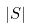<formula> <loc_0><loc_0><loc_500><loc_500>\left | S \right |</formula> 